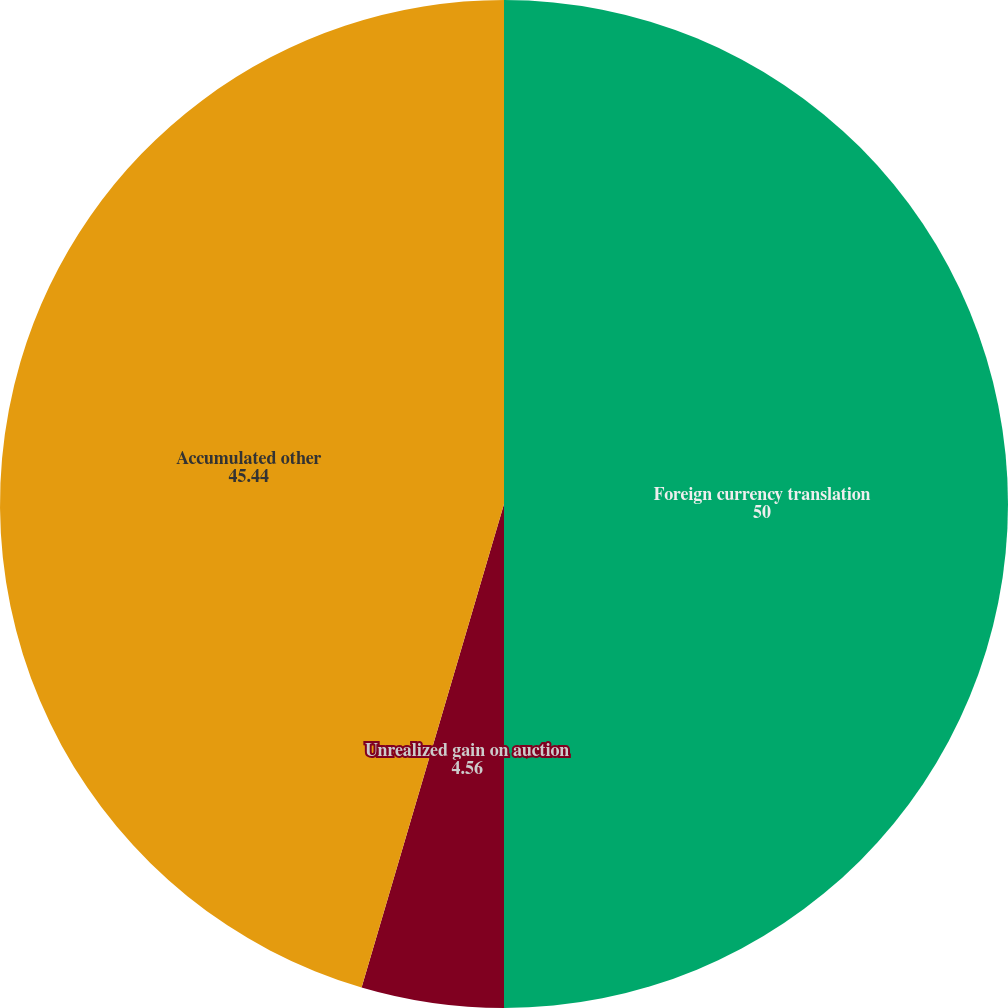Convert chart. <chart><loc_0><loc_0><loc_500><loc_500><pie_chart><fcel>Foreign currency translation<fcel>Unrealized gain on auction<fcel>Unrealized gain on derivatives<fcel>Accumulated other<nl><fcel>50.0%<fcel>4.56%<fcel>0.0%<fcel>45.44%<nl></chart> 